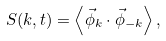Convert formula to latex. <formula><loc_0><loc_0><loc_500><loc_500>S ( { k } , t ) = \left < \vec { \phi } _ { k } \cdot \vec { \phi } _ { - { k } } \right > ,</formula> 